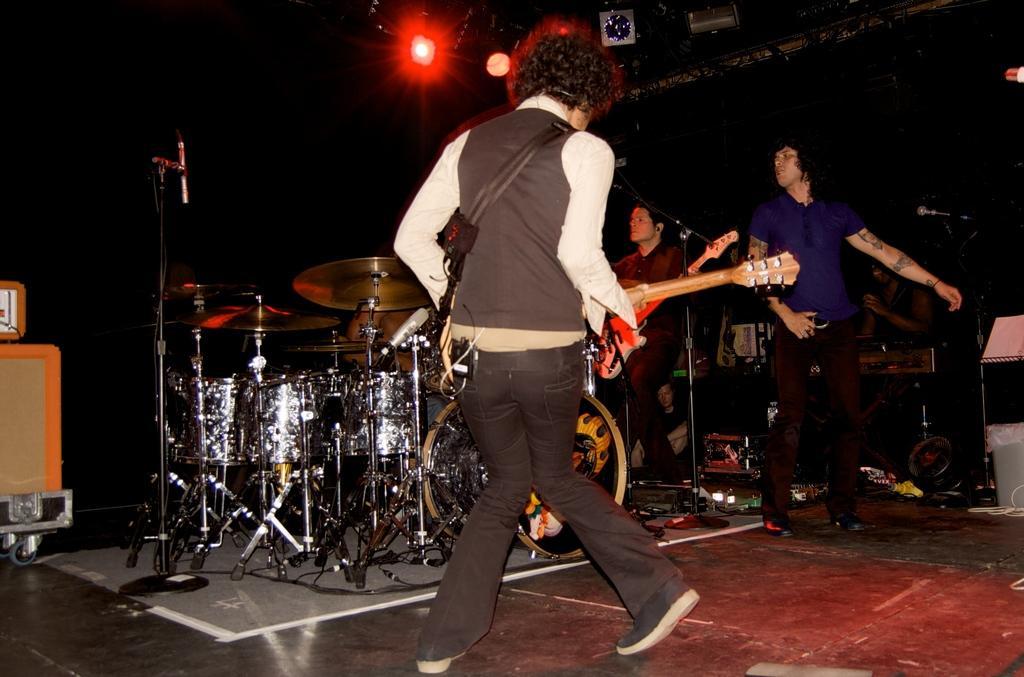Describe this image in one or two sentences. In this image I can see four people. Among them two people are holding the musical instruments and there is a drum set on the stage. In the background there is a light. 